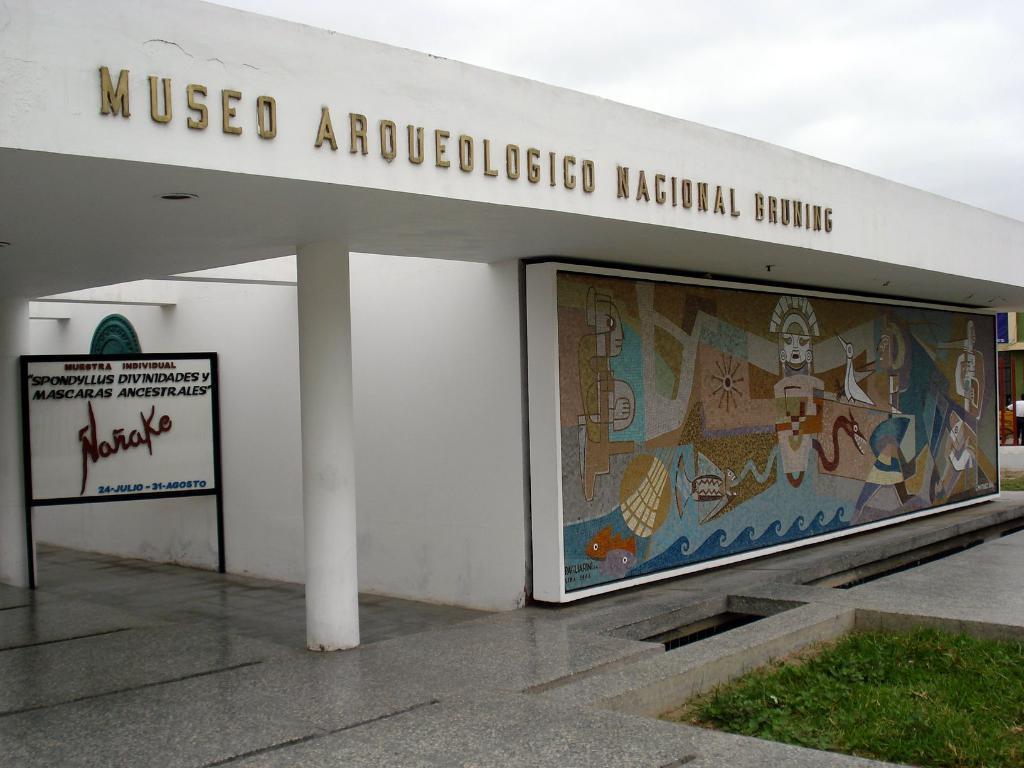Describe this image in one or two sentences. This image consists of a building in white color. In the front, there is a board. At the bottom, there is a floor along with grass. In the middle, there is a pillar. 